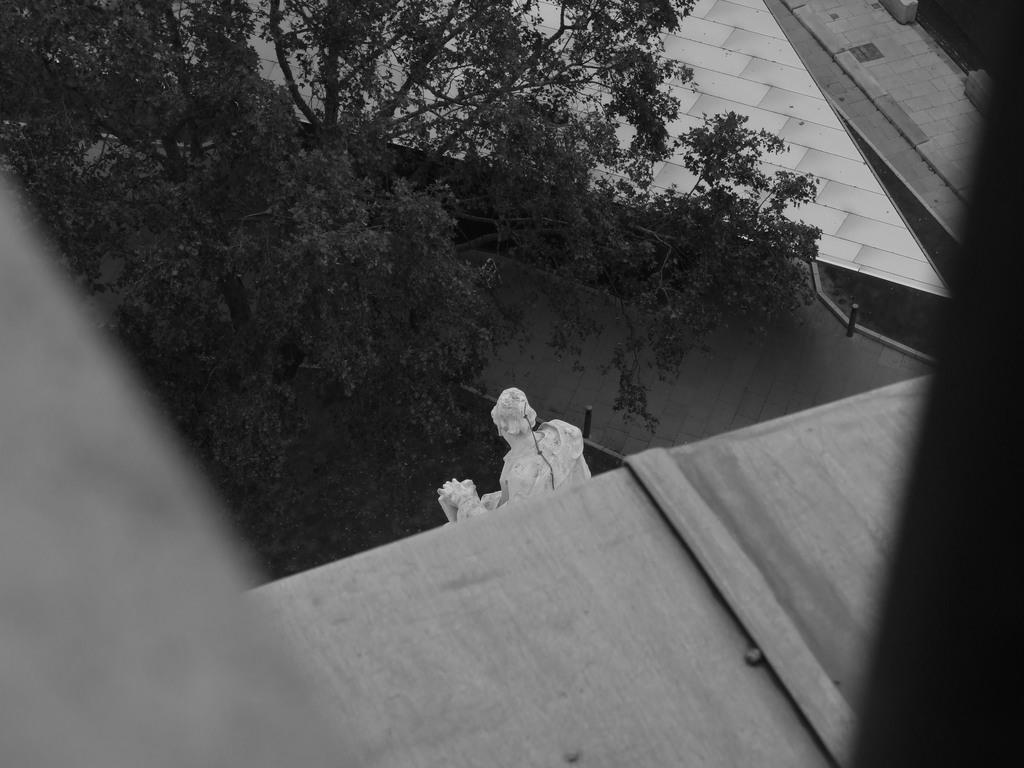Please provide a concise description of this image. This is a black and white image. In this image we can see a statue. Also there is a tree. And we can see roof of a building. 